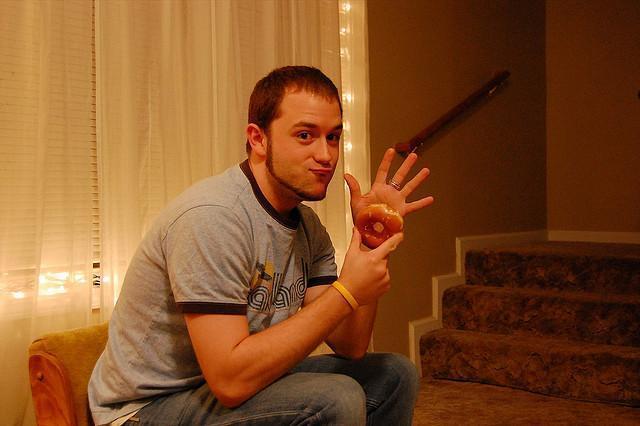What flavor is the donut?
From the following four choices, select the correct answer to address the question.
Options: Chocolate, carrot, caramel, lemon. Caramel. 